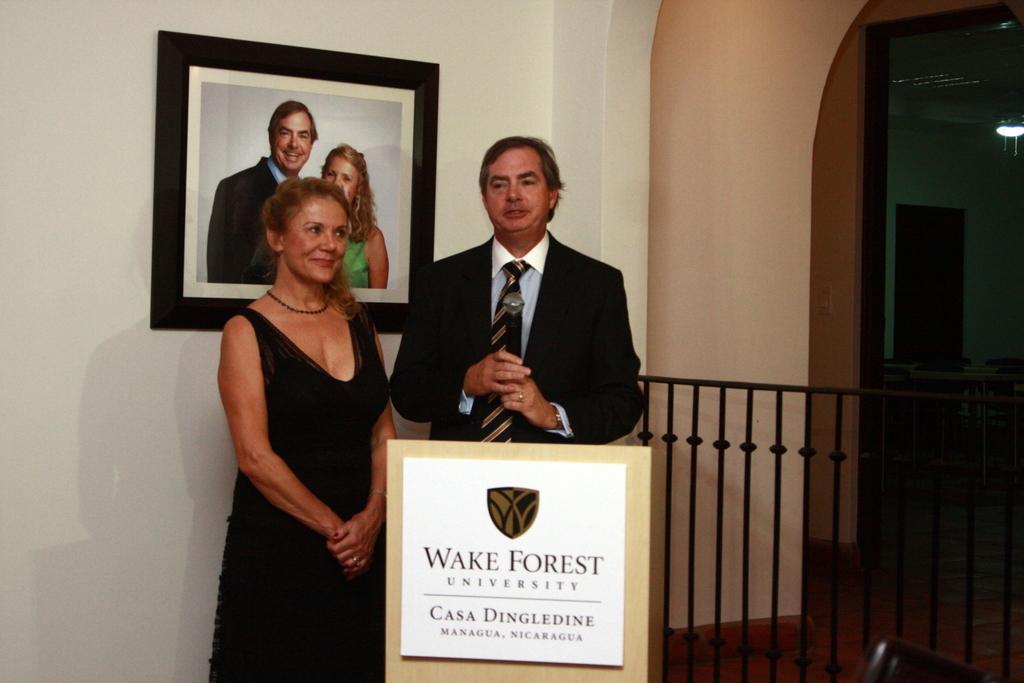Could you give a brief overview of what you see in this image? In the picture we can see a man and a woman standing, a man is wearing a blazer with tie and shirt and the woman is wearing a black dress and in the background we can see a wall with a photo frame of man and woman. 